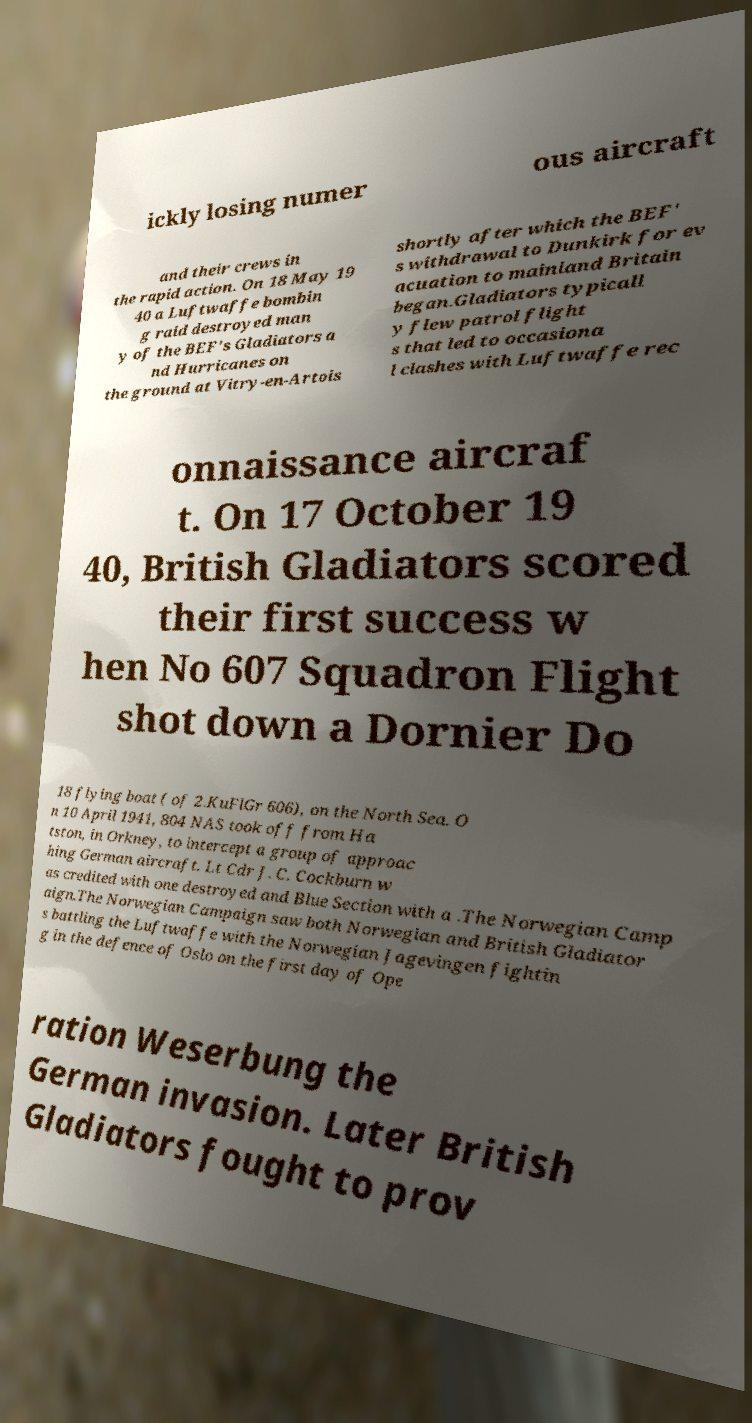Please read and relay the text visible in this image. What does it say? ickly losing numer ous aircraft and their crews in the rapid action. On 18 May 19 40 a Luftwaffe bombin g raid destroyed man y of the BEF's Gladiators a nd Hurricanes on the ground at Vitry-en-Artois shortly after which the BEF' s withdrawal to Dunkirk for ev acuation to mainland Britain began.Gladiators typicall y flew patrol flight s that led to occasiona l clashes with Luftwaffe rec onnaissance aircraf t. On 17 October 19 40, British Gladiators scored their first success w hen No 607 Squadron Flight shot down a Dornier Do 18 flying boat ( of 2.KuFlGr 606), on the North Sea. O n 10 April 1941, 804 NAS took off from Ha tston, in Orkney, to intercept a group of approac hing German aircraft. Lt Cdr J. C. Cockburn w as credited with one destroyed and Blue Section with a .The Norwegian Camp aign.The Norwegian Campaign saw both Norwegian and British Gladiator s battling the Luftwaffe with the Norwegian Jagevingen fightin g in the defence of Oslo on the first day of Ope ration Weserbung the German invasion. Later British Gladiators fought to prov 